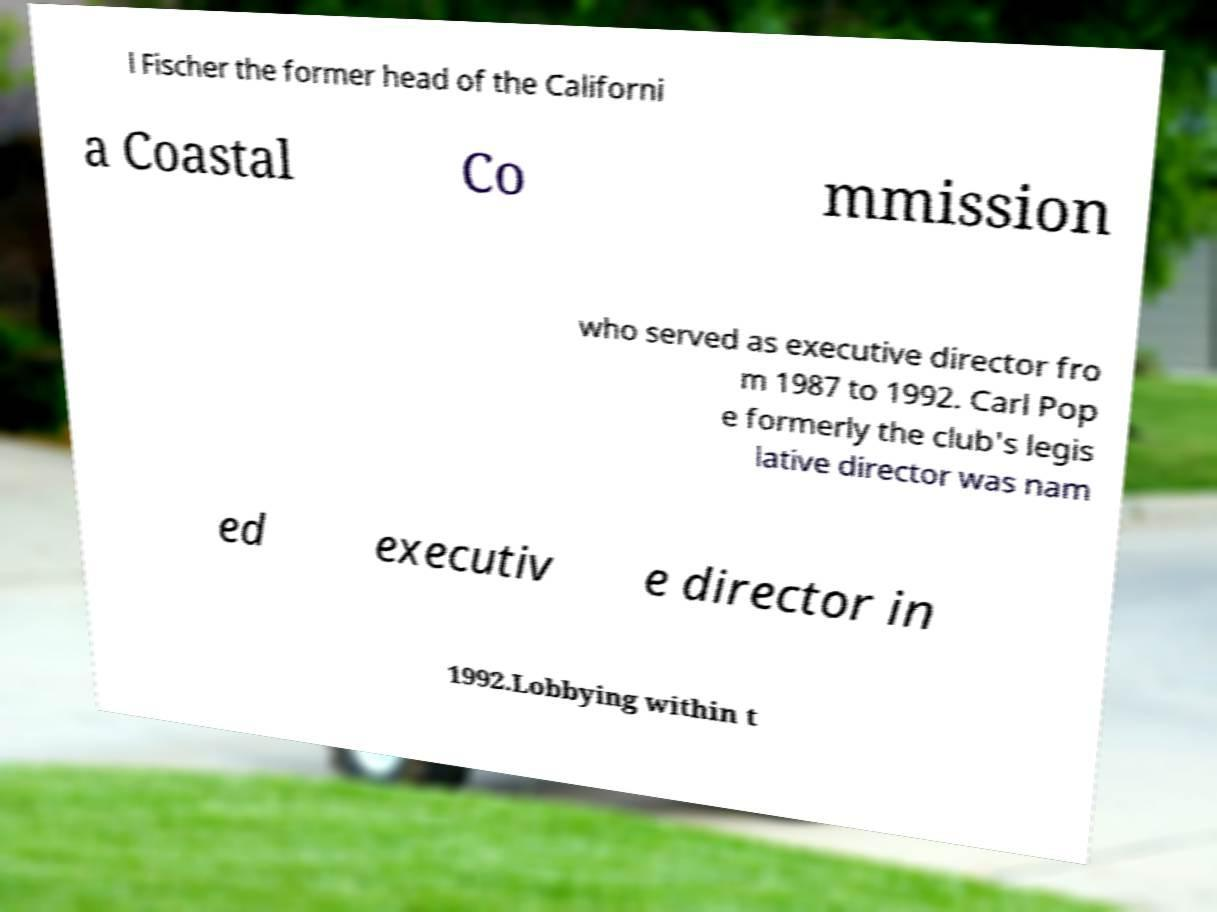I need the written content from this picture converted into text. Can you do that? l Fischer the former head of the Californi a Coastal Co mmission who served as executive director fro m 1987 to 1992. Carl Pop e formerly the club's legis lative director was nam ed executiv e director in 1992.Lobbying within t 